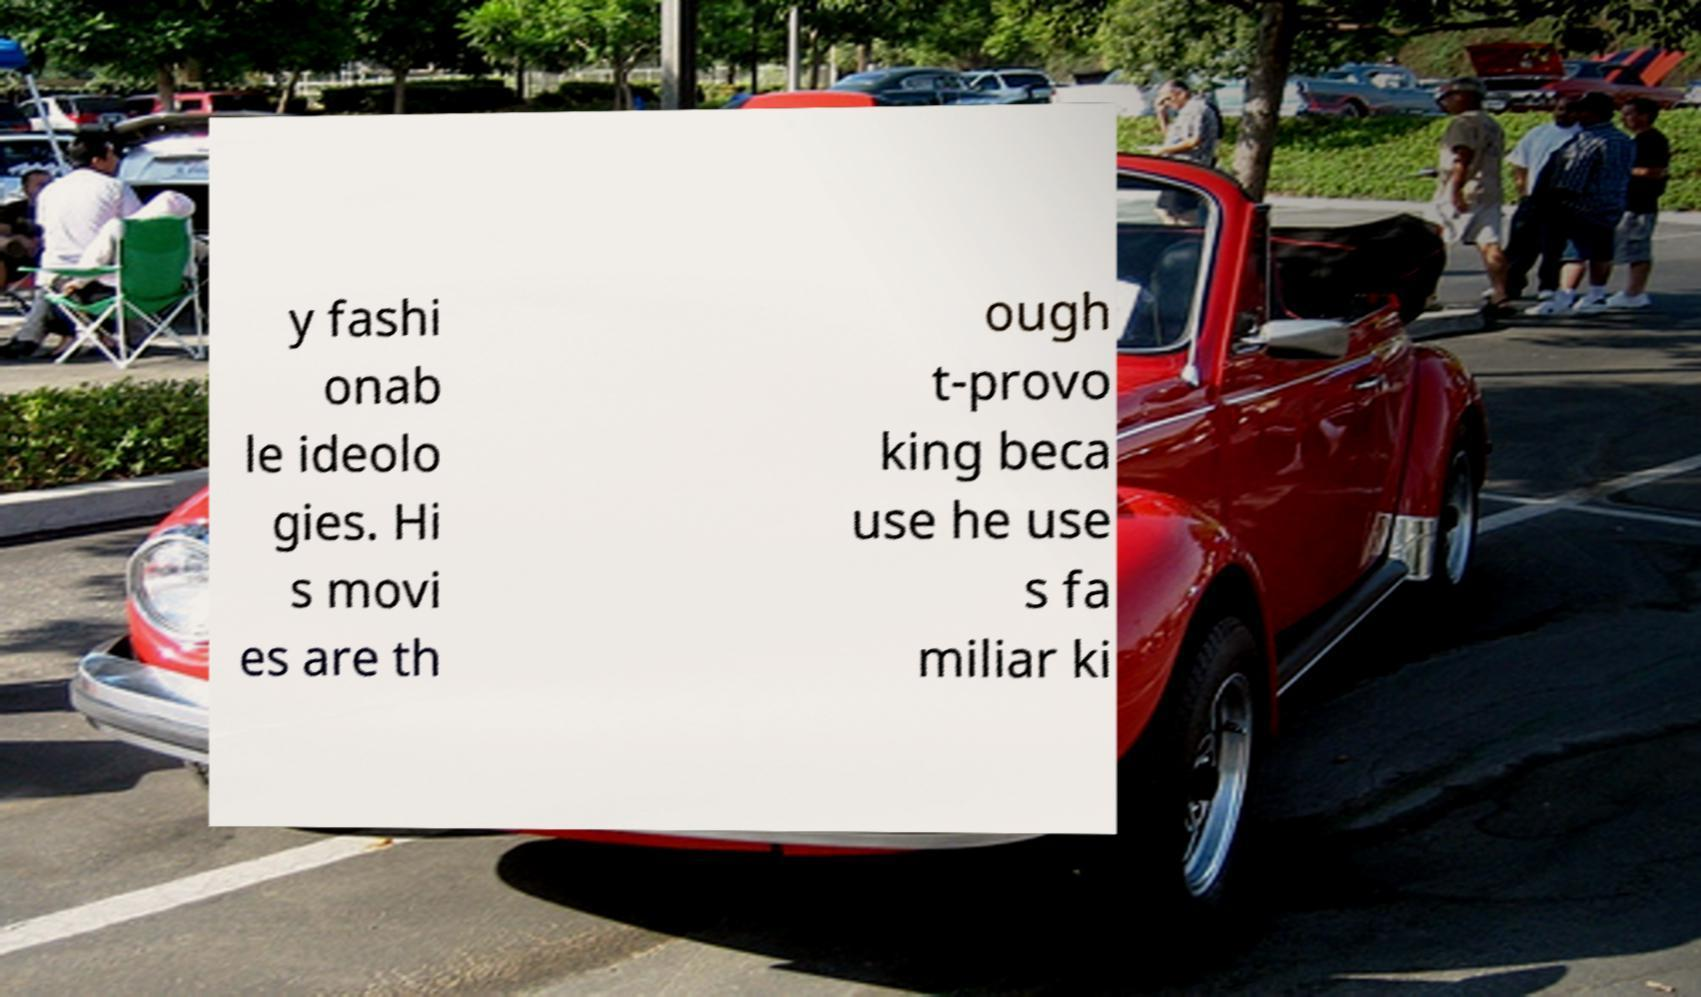Could you extract and type out the text from this image? y fashi onab le ideolo gies. Hi s movi es are th ough t-provo king beca use he use s fa miliar ki 